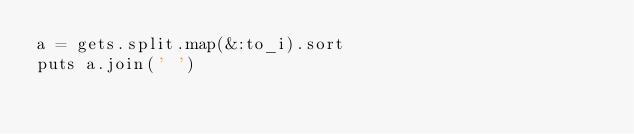Convert code to text. <code><loc_0><loc_0><loc_500><loc_500><_Ruby_>a = gets.split.map(&:to_i).sort
puts a.join(' ')
</code> 